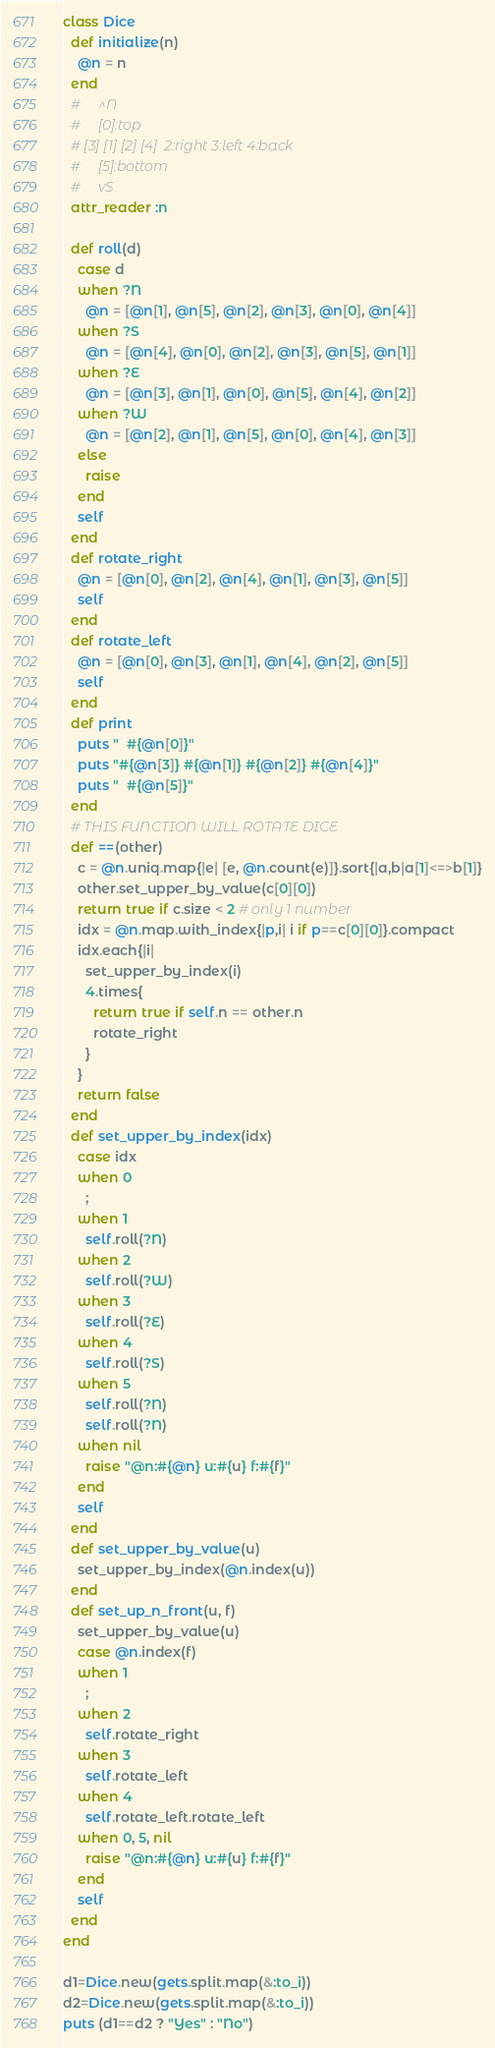Convert code to text. <code><loc_0><loc_0><loc_500><loc_500><_Ruby_>class Dice
  def initialize(n)
    @n = n
  end
  #     ^N
  #     [0]:top
  # [3] [1] [2] [4]  2:right 3:left 4:back
  #     [5]:bottom
  #     vS
  attr_reader :n

  def roll(d)
    case d
    when ?N
      @n = [@n[1], @n[5], @n[2], @n[3], @n[0], @n[4]]
    when ?S
      @n = [@n[4], @n[0], @n[2], @n[3], @n[5], @n[1]]
    when ?E
      @n = [@n[3], @n[1], @n[0], @n[5], @n[4], @n[2]]
    when ?W
      @n = [@n[2], @n[1], @n[5], @n[0], @n[4], @n[3]]
    else
      raise
    end
    self
  end
  def rotate_right
    @n = [@n[0], @n[2], @n[4], @n[1], @n[3], @n[5]]
    self
  end
  def rotate_left
    @n = [@n[0], @n[3], @n[1], @n[4], @n[2], @n[5]]
    self
  end
  def print
    puts "  #{@n[0]}"
    puts "#{@n[3]} #{@n[1]} #{@n[2]} #{@n[4]}"
    puts "  #{@n[5]}"
  end
  # THIS FUNCTION WILL ROTATE DICE
  def ==(other)
    c = @n.uniq.map{|e| [e, @n.count(e)]}.sort{|a,b|a[1]<=>b[1]}
    other.set_upper_by_value(c[0][0])
    return true if c.size < 2 # only 1 number
    idx = @n.map.with_index{|p,i| i if p==c[0][0]}.compact
    idx.each{|i|
      set_upper_by_index(i)
      4.times{
        return true if self.n == other.n
        rotate_right
      }
    }
    return false
  end
  def set_upper_by_index(idx)
    case idx
    when 0
      ;
    when 1
      self.roll(?N)
    when 2
      self.roll(?W)
    when 3
      self.roll(?E)
    when 4
      self.roll(?S)
    when 5
      self.roll(?N)
      self.roll(?N)
    when nil
      raise "@n:#{@n} u:#{u} f:#{f}"
    end
    self
  end
  def set_upper_by_value(u)
    set_upper_by_index(@n.index(u))
  end
  def set_up_n_front(u, f)
    set_upper_by_value(u)
    case @n.index(f)
    when 1
      ;
    when 2
      self.rotate_right
    when 3
      self.rotate_left
    when 4
      self.rotate_left.rotate_left
    when 0, 5, nil
      raise "@n:#{@n} u:#{u} f:#{f}"
    end
    self
  end
end

d1=Dice.new(gets.split.map(&:to_i))
d2=Dice.new(gets.split.map(&:to_i))
puts (d1==d2 ? "Yes" : "No")

</code> 